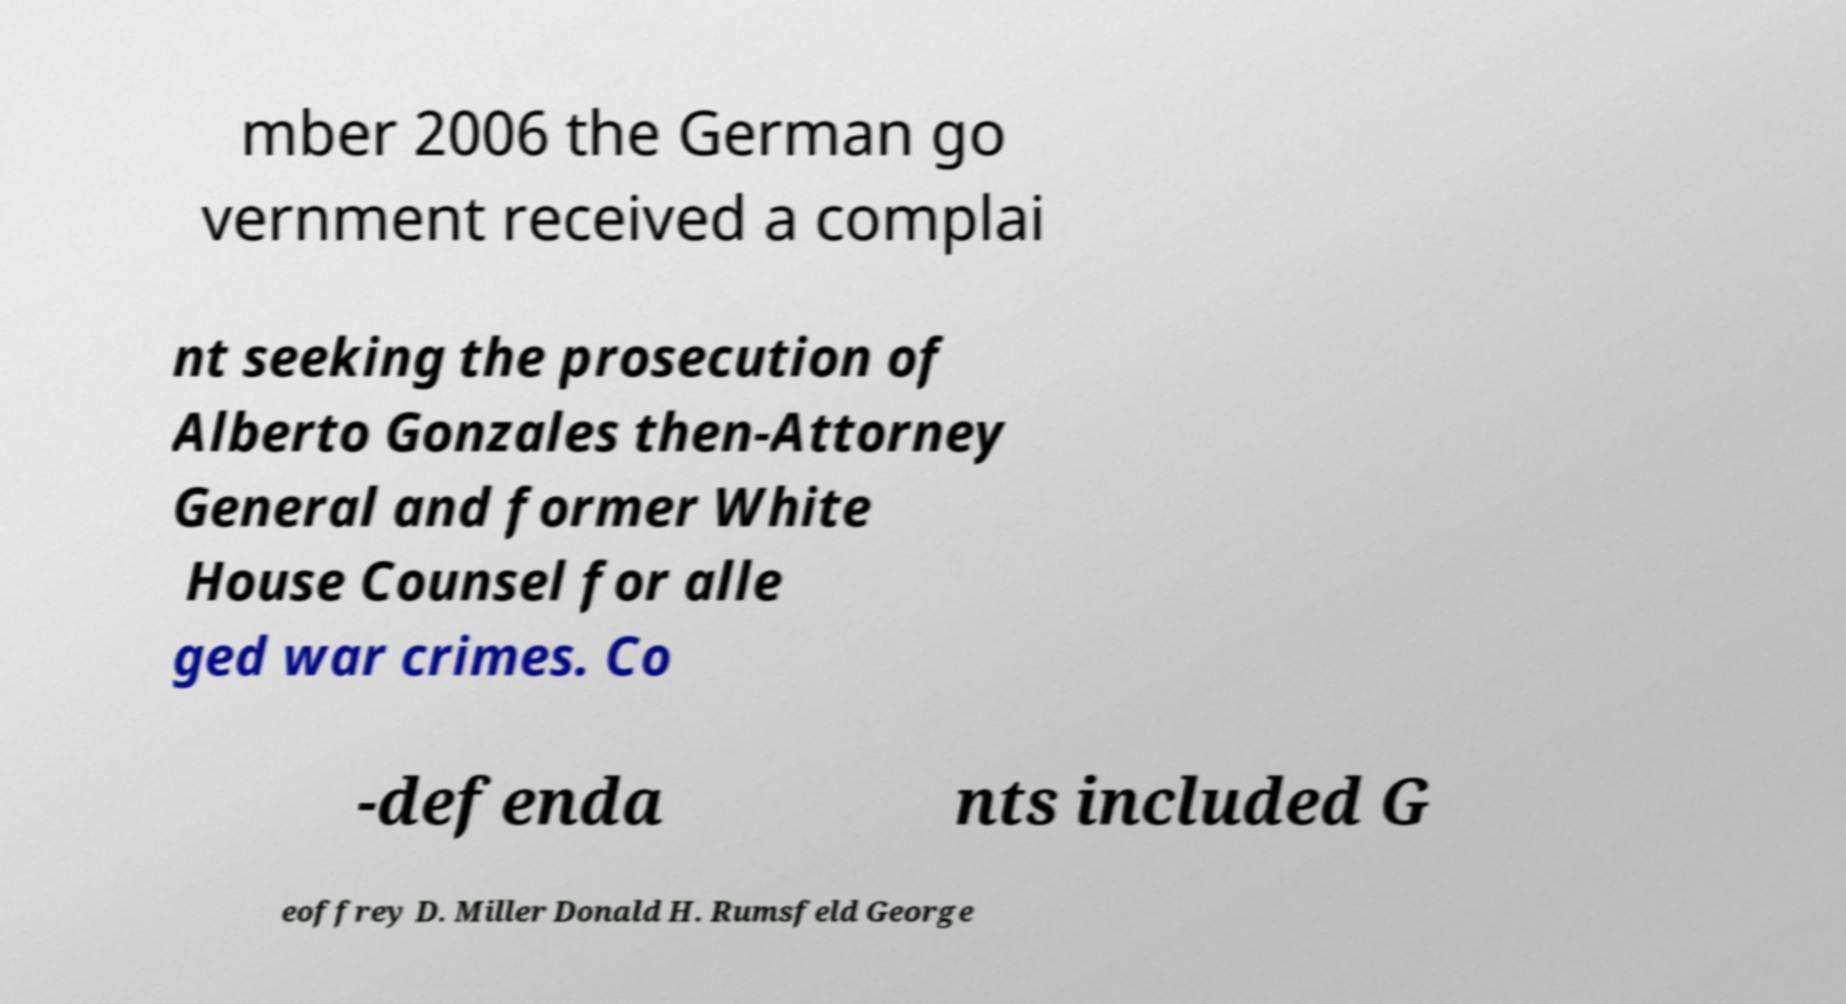Can you accurately transcribe the text from the provided image for me? mber 2006 the German go vernment received a complai nt seeking the prosecution of Alberto Gonzales then-Attorney General and former White House Counsel for alle ged war crimes. Co -defenda nts included G eoffrey D. Miller Donald H. Rumsfeld George 